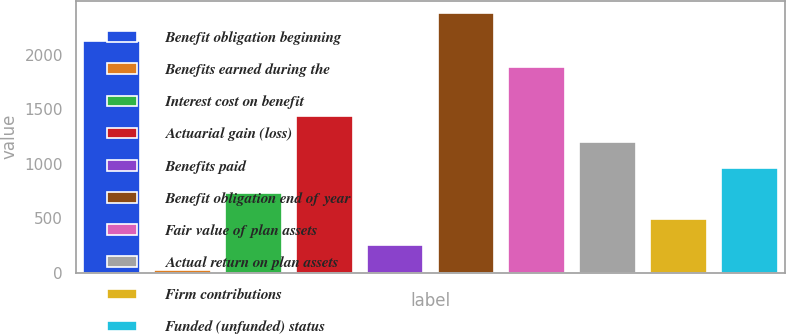Convert chart to OTSL. <chart><loc_0><loc_0><loc_500><loc_500><bar_chart><fcel>Benefit obligation beginning<fcel>Benefits earned during the<fcel>Interest cost on benefit<fcel>Actuarial gain (loss)<fcel>Benefits paid<fcel>Benefit obligation end of year<fcel>Fair value of plan assets<fcel>Actual return on plan assets<fcel>Firm contributions<fcel>Funded (unfunded) status<nl><fcel>2124.3<fcel>25<fcel>730.9<fcel>1436.8<fcel>260.3<fcel>2378<fcel>1889<fcel>1201.5<fcel>495.6<fcel>966.2<nl></chart> 